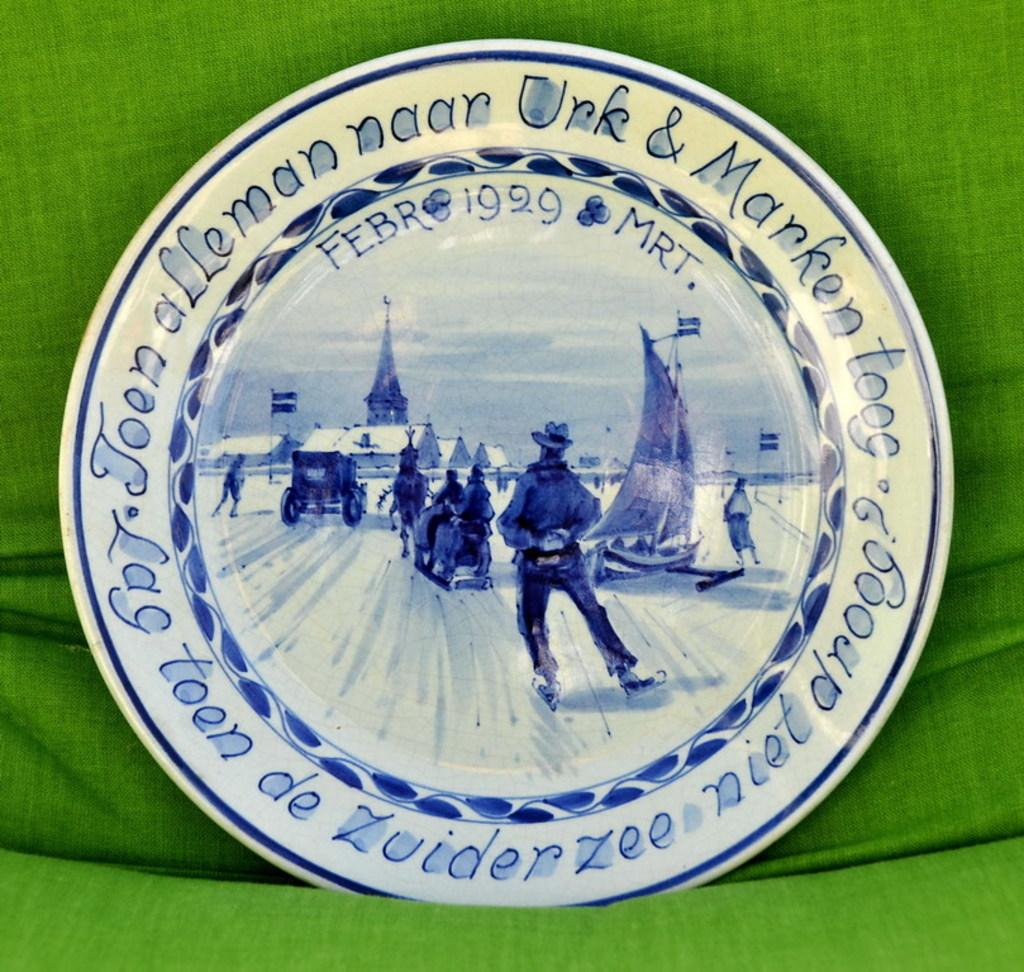What object is present on the couch in the image? There is a plate on the couch in the image. What can be seen on the plate? The plate has designs depicting a person, a car, a chariot, flags, buildings, a boat, the sky, and clouds. How many kittens are playing on the page in the image? There are no kittens or pages present in the image; it features a plate with various designs. What type of music is the band playing in the image? There is no band present in the image; it features a plate with various designs. 